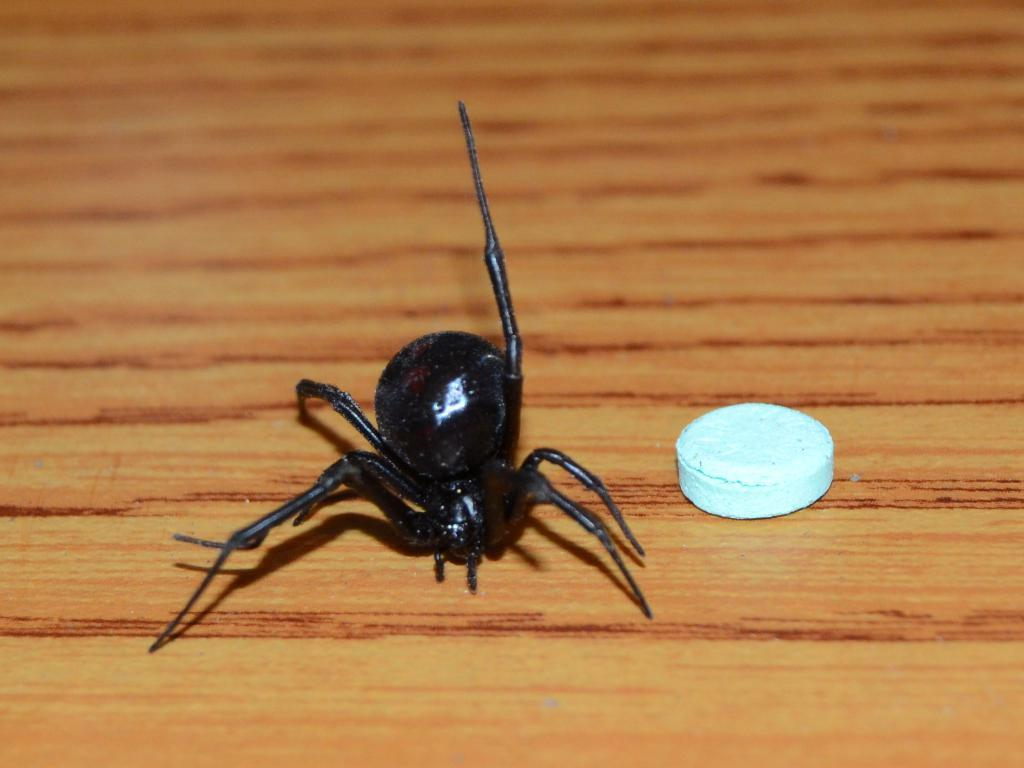What is the main subject of the image? There is a spider in the image. What else can be seen in the image besides the spider? There is a medical tablet in the image. Where are the spider and the medical tablet located? Both the spider and the medical tablet are on a wooden board. What type of beggar can be seen in the image? There is no beggar present in the image. In which bedroom is the spider and medical tablet located? The image does not provide any information about the location of the spider and medical tablet being in a bedroom. 